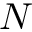<formula> <loc_0><loc_0><loc_500><loc_500>N</formula> 